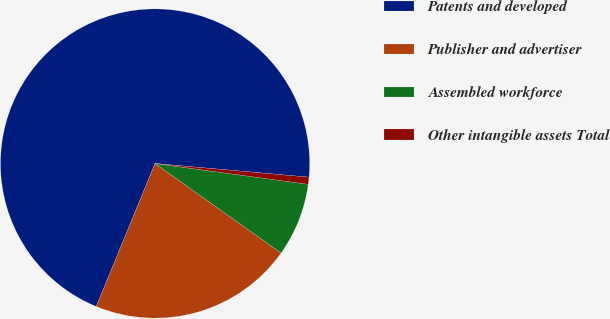Convert chart to OTSL. <chart><loc_0><loc_0><loc_500><loc_500><pie_chart><fcel>Patents and developed<fcel>Publisher and advertiser<fcel>Assembled workforce<fcel>Other intangible assets Total<nl><fcel>70.2%<fcel>21.38%<fcel>7.68%<fcel>0.74%<nl></chart> 